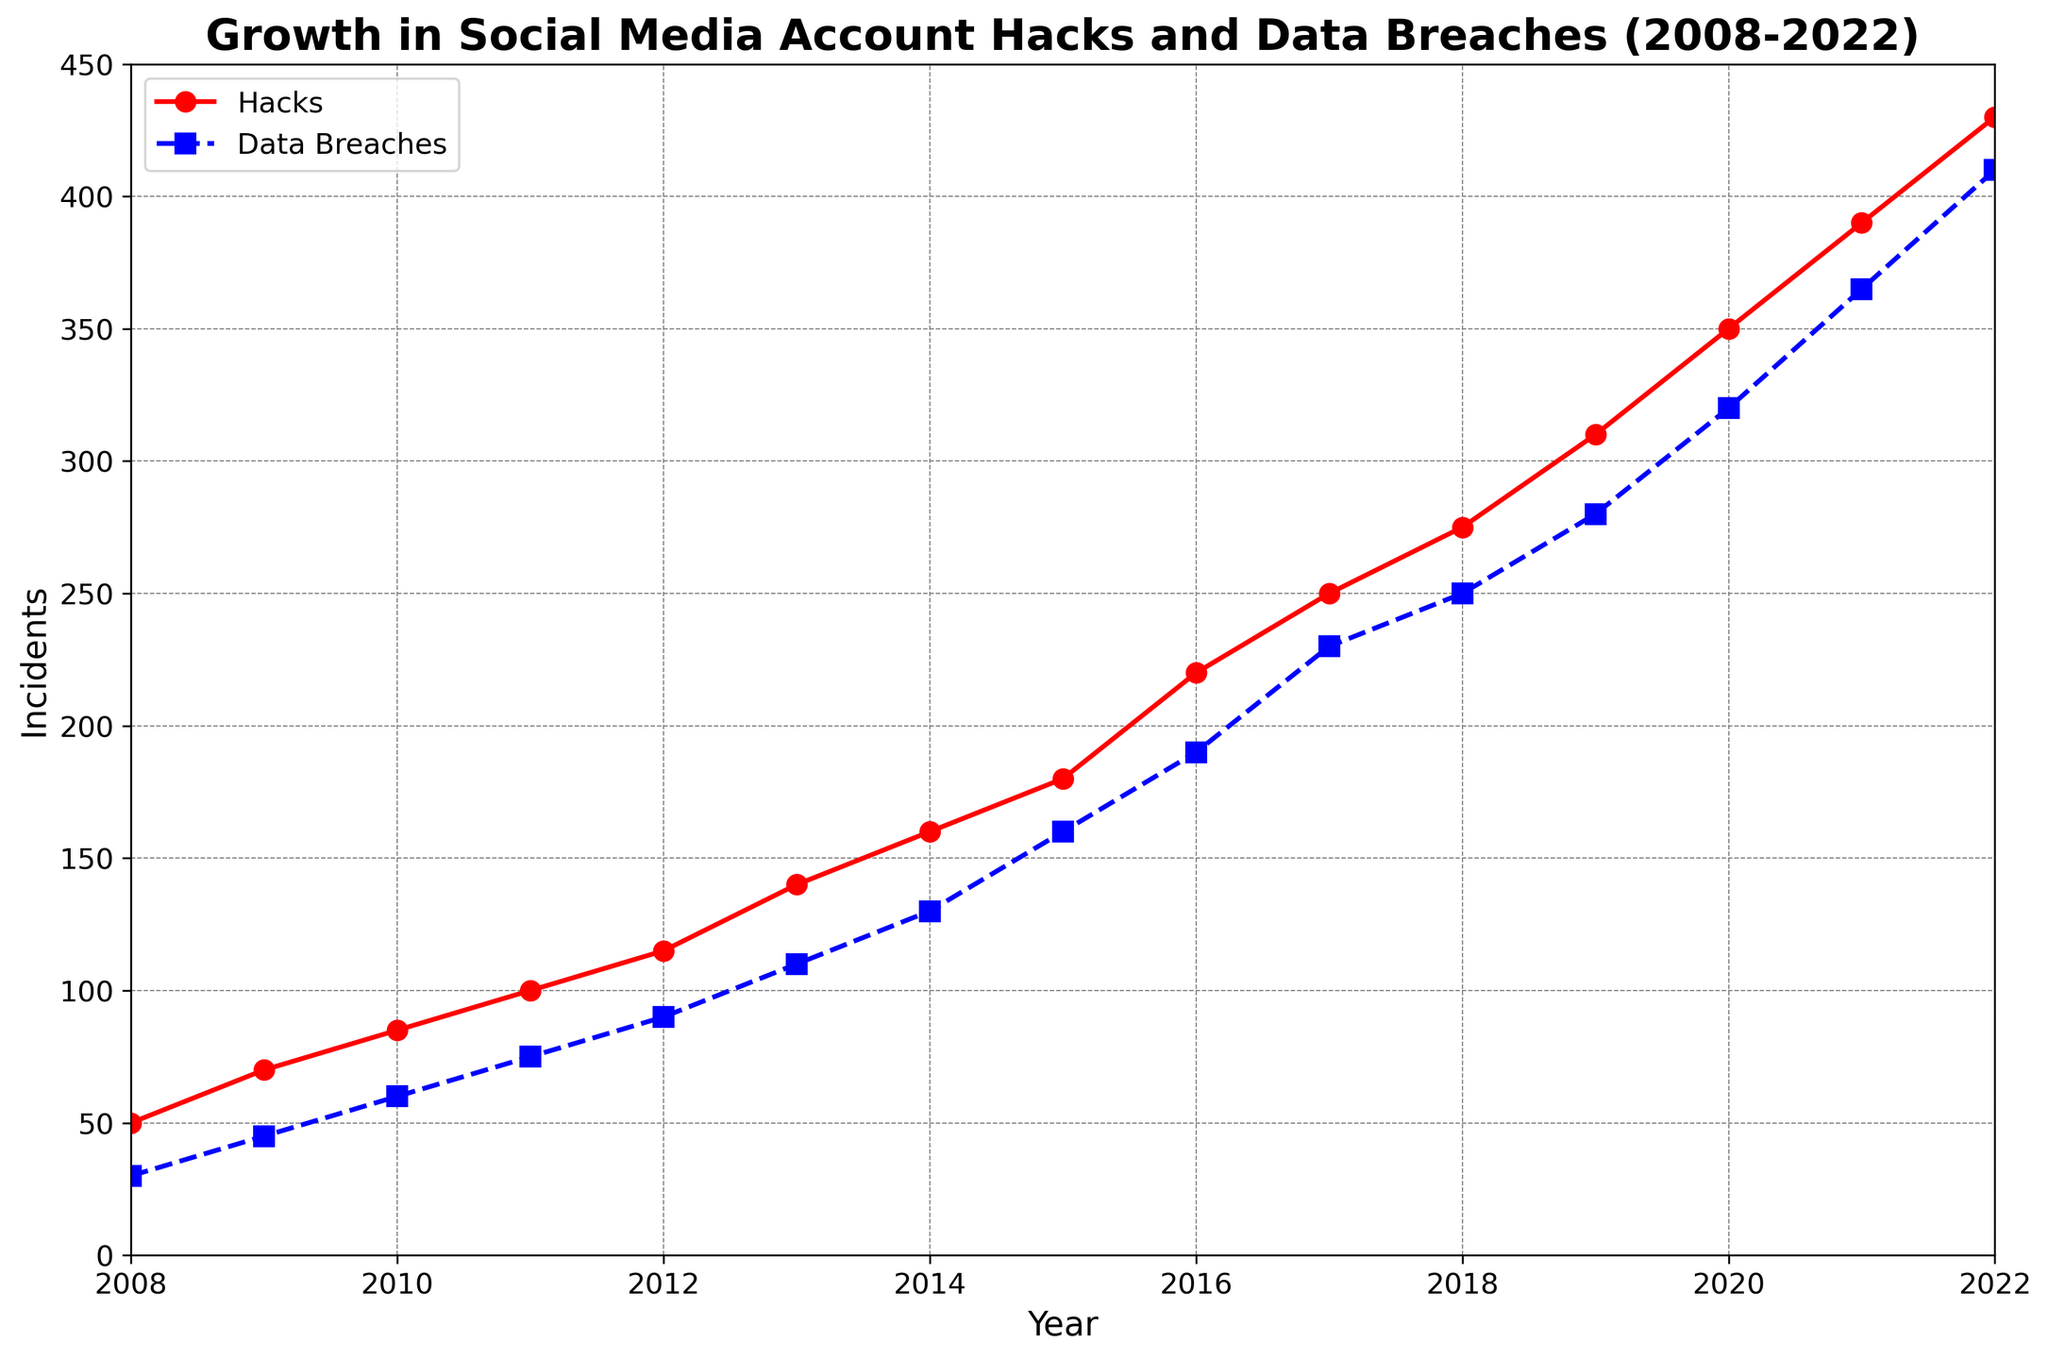What's the general trend in social media account hacks over the 15 years? The plot shows a consistent increase in the number of social media account hacks over the given period. Observing the red line that represents hacks, it trends upwards from 2008 to 2022.
Answer: Increasing During which year did data breaches surpass 200 incidents? By examining the blue dashed line that represents data breaches, the number of incidents crosses 200 in the year 2017.
Answer: 2017 What's the difference in the number of hacks between the years 2020 and 2022? The plot shows 350 hacks in 2020 and 430 hacks in 2022. The difference is calculated as 430 - 350.
Answer: 80 Which had a higher growth rate: hacks or data breaches from 2010 to 2022? Calculating the increase for hacks: 430 (2022) - 85 (2010) = 345. For data breaches: 410 (2022) - 60 (2010) = 350. Comparing the two, data breaches grew slightly more.
Answer: Data Breaches What color represents social media account hacks in the plot? The plot uses a red line to represent social media account hacks.
Answer: Red In which years were hacks and data breaches equal? A detailed look at the lines shows no points where both the red (hacks) and the blue (data breaches) lines intersect, so the values were never equal.
Answer: Never How many more hacks were there compared to data breaches in 2013? In 2013, the plot shows approximately 140 hacks and 110 data breaches. The difference is 140 - 110.
Answer: 30 What's the average number of incidents (both hacks and data breaches) in 2015? In 2015, there were 180 hacks and 160 data breaches. The average is (180 + 160) / 2.
Answer: 170 How does the trend of data breaches visually compare to the trend of social media hacks? Both trends rise, but the hacks (red line) appear to have a steeper and more consistent increase compared to the data breaches (blue dashed line), which has a more moderate slope.
Answer: Steeper for Hacks 